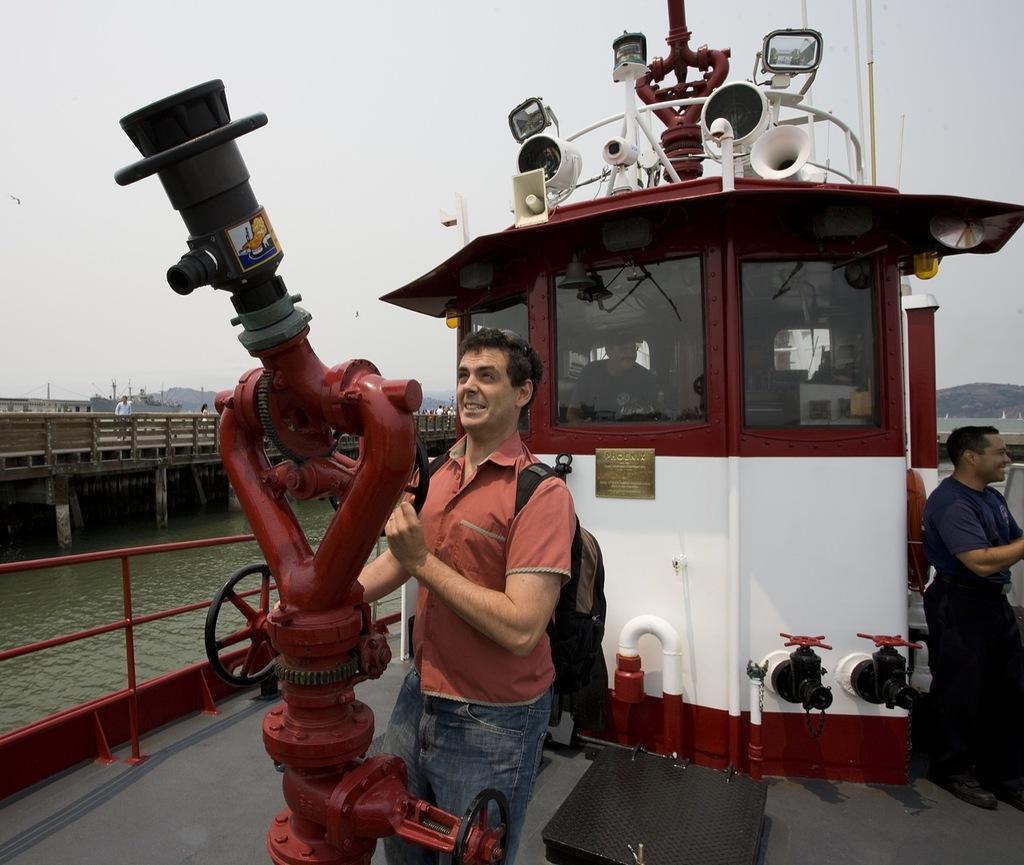Describe this image in one or two sentences. In the center of the image we can see a boat, machines, steering, lights and some persons. In the background of the image we can see the water, bridge, mountains, poles, house and some persons. At the top of the image we can see the sky. 